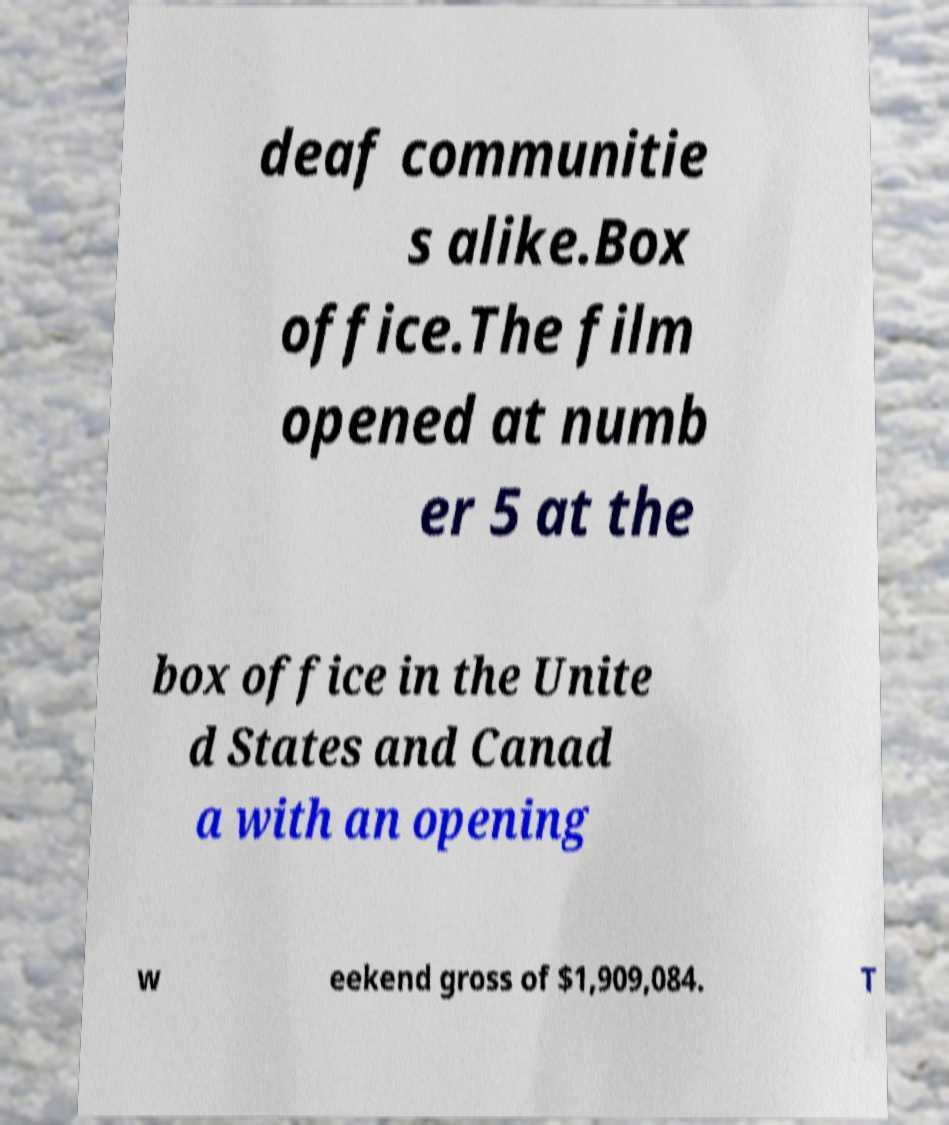Please read and relay the text visible in this image. What does it say? deaf communitie s alike.Box office.The film opened at numb er 5 at the box office in the Unite d States and Canad a with an opening w eekend gross of $1,909,084. T 